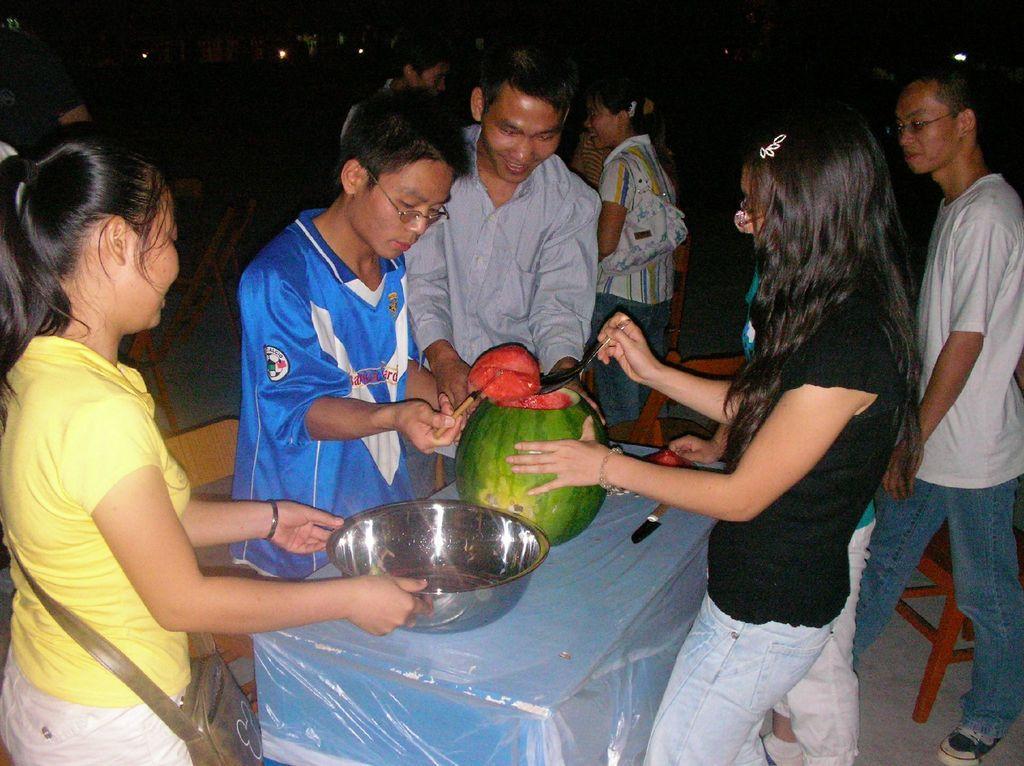Could you give a brief overview of what you see in this image? There are people standing and she carrying a bag and holding a bowl. We can see watermelon, bowl, knife and cover on the table and chairs. In the background it is dark and we can see lights. 